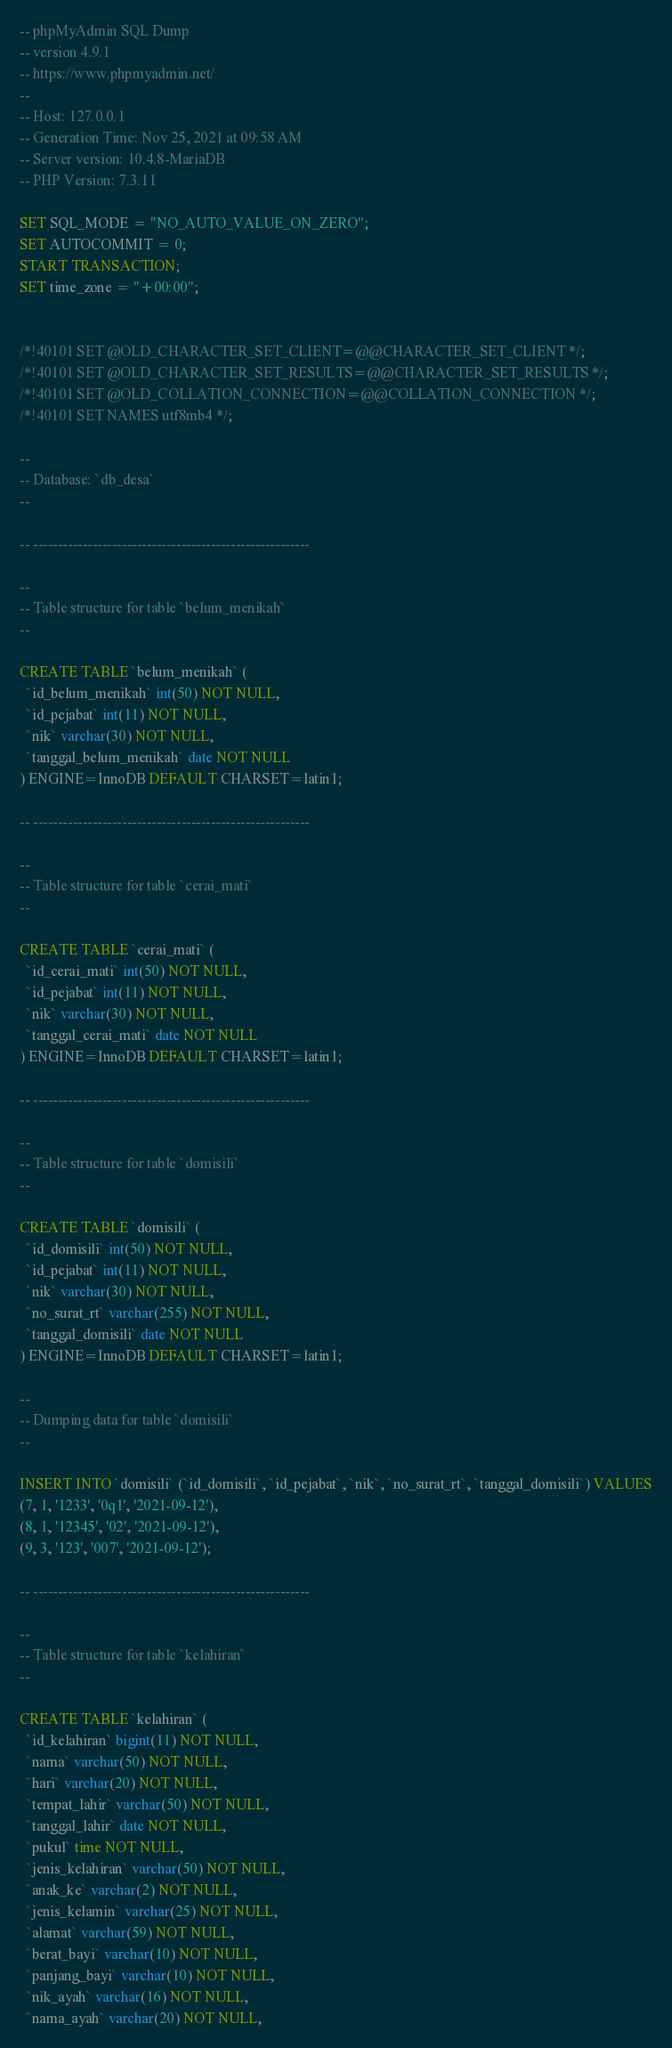Convert code to text. <code><loc_0><loc_0><loc_500><loc_500><_SQL_>-- phpMyAdmin SQL Dump
-- version 4.9.1
-- https://www.phpmyadmin.net/
--
-- Host: 127.0.0.1
-- Generation Time: Nov 25, 2021 at 09:58 AM
-- Server version: 10.4.8-MariaDB
-- PHP Version: 7.3.11

SET SQL_MODE = "NO_AUTO_VALUE_ON_ZERO";
SET AUTOCOMMIT = 0;
START TRANSACTION;
SET time_zone = "+00:00";


/*!40101 SET @OLD_CHARACTER_SET_CLIENT=@@CHARACTER_SET_CLIENT */;
/*!40101 SET @OLD_CHARACTER_SET_RESULTS=@@CHARACTER_SET_RESULTS */;
/*!40101 SET @OLD_COLLATION_CONNECTION=@@COLLATION_CONNECTION */;
/*!40101 SET NAMES utf8mb4 */;

--
-- Database: `db_desa`
--

-- --------------------------------------------------------

--
-- Table structure for table `belum_menikah`
--

CREATE TABLE `belum_menikah` (
  `id_belum_menikah` int(50) NOT NULL,
  `id_pejabat` int(11) NOT NULL,
  `nik` varchar(30) NOT NULL,
  `tanggal_belum_menikah` date NOT NULL
) ENGINE=InnoDB DEFAULT CHARSET=latin1;

-- --------------------------------------------------------

--
-- Table structure for table `cerai_mati`
--

CREATE TABLE `cerai_mati` (
  `id_cerai_mati` int(50) NOT NULL,
  `id_pejabat` int(11) NOT NULL,
  `nik` varchar(30) NOT NULL,
  `tanggal_cerai_mati` date NOT NULL
) ENGINE=InnoDB DEFAULT CHARSET=latin1;

-- --------------------------------------------------------

--
-- Table structure for table `domisili`
--

CREATE TABLE `domisili` (
  `id_domisili` int(50) NOT NULL,
  `id_pejabat` int(11) NOT NULL,
  `nik` varchar(30) NOT NULL,
  `no_surat_rt` varchar(255) NOT NULL,
  `tanggal_domisili` date NOT NULL
) ENGINE=InnoDB DEFAULT CHARSET=latin1;

--
-- Dumping data for table `domisili`
--

INSERT INTO `domisili` (`id_domisili`, `id_pejabat`, `nik`, `no_surat_rt`, `tanggal_domisili`) VALUES
(7, 1, '1233', '0q1', '2021-09-12'),
(8, 1, '12345', '02', '2021-09-12'),
(9, 3, '123', '007', '2021-09-12');

-- --------------------------------------------------------

--
-- Table structure for table `kelahiran`
--

CREATE TABLE `kelahiran` (
  `id_kelahiran` bigint(11) NOT NULL,
  `nama` varchar(50) NOT NULL,
  `hari` varchar(20) NOT NULL,
  `tempat_lahir` varchar(50) NOT NULL,
  `tanggal_lahir` date NOT NULL,
  `pukul` time NOT NULL,
  `jenis_kelahiran` varchar(50) NOT NULL,
  `anak_ke` varchar(2) NOT NULL,
  `jenis_kelamin` varchar(25) NOT NULL,
  `alamat` varchar(59) NOT NULL,
  `berat_bayi` varchar(10) NOT NULL,
  `panjang_bayi` varchar(10) NOT NULL,
  `nik_ayah` varchar(16) NOT NULL,
  `nama_ayah` varchar(20) NOT NULL,</code> 